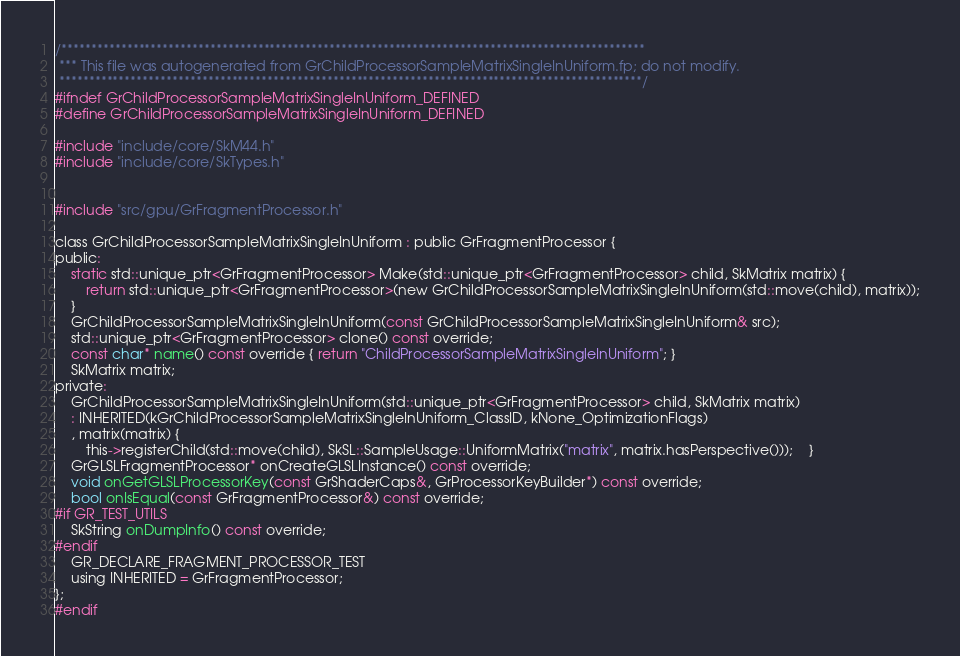<code> <loc_0><loc_0><loc_500><loc_500><_C_>

/**************************************************************************************************
 *** This file was autogenerated from GrChildProcessorSampleMatrixSingleInUniform.fp; do not modify.
 **************************************************************************************************/
#ifndef GrChildProcessorSampleMatrixSingleInUniform_DEFINED
#define GrChildProcessorSampleMatrixSingleInUniform_DEFINED

#include "include/core/SkM44.h"
#include "include/core/SkTypes.h"


#include "src/gpu/GrFragmentProcessor.h"

class GrChildProcessorSampleMatrixSingleInUniform : public GrFragmentProcessor {
public:
    static std::unique_ptr<GrFragmentProcessor> Make(std::unique_ptr<GrFragmentProcessor> child, SkMatrix matrix) {
        return std::unique_ptr<GrFragmentProcessor>(new GrChildProcessorSampleMatrixSingleInUniform(std::move(child), matrix));
    }
    GrChildProcessorSampleMatrixSingleInUniform(const GrChildProcessorSampleMatrixSingleInUniform& src);
    std::unique_ptr<GrFragmentProcessor> clone() const override;
    const char* name() const override { return "ChildProcessorSampleMatrixSingleInUniform"; }
    SkMatrix matrix;
private:
    GrChildProcessorSampleMatrixSingleInUniform(std::unique_ptr<GrFragmentProcessor> child, SkMatrix matrix)
    : INHERITED(kGrChildProcessorSampleMatrixSingleInUniform_ClassID, kNone_OptimizationFlags)
    , matrix(matrix) {
        this->registerChild(std::move(child), SkSL::SampleUsage::UniformMatrix("matrix", matrix.hasPerspective()));    }
    GrGLSLFragmentProcessor* onCreateGLSLInstance() const override;
    void onGetGLSLProcessorKey(const GrShaderCaps&, GrProcessorKeyBuilder*) const override;
    bool onIsEqual(const GrFragmentProcessor&) const override;
#if GR_TEST_UTILS
    SkString onDumpInfo() const override;
#endif
    GR_DECLARE_FRAGMENT_PROCESSOR_TEST
    using INHERITED = GrFragmentProcessor;
};
#endif
</code> 